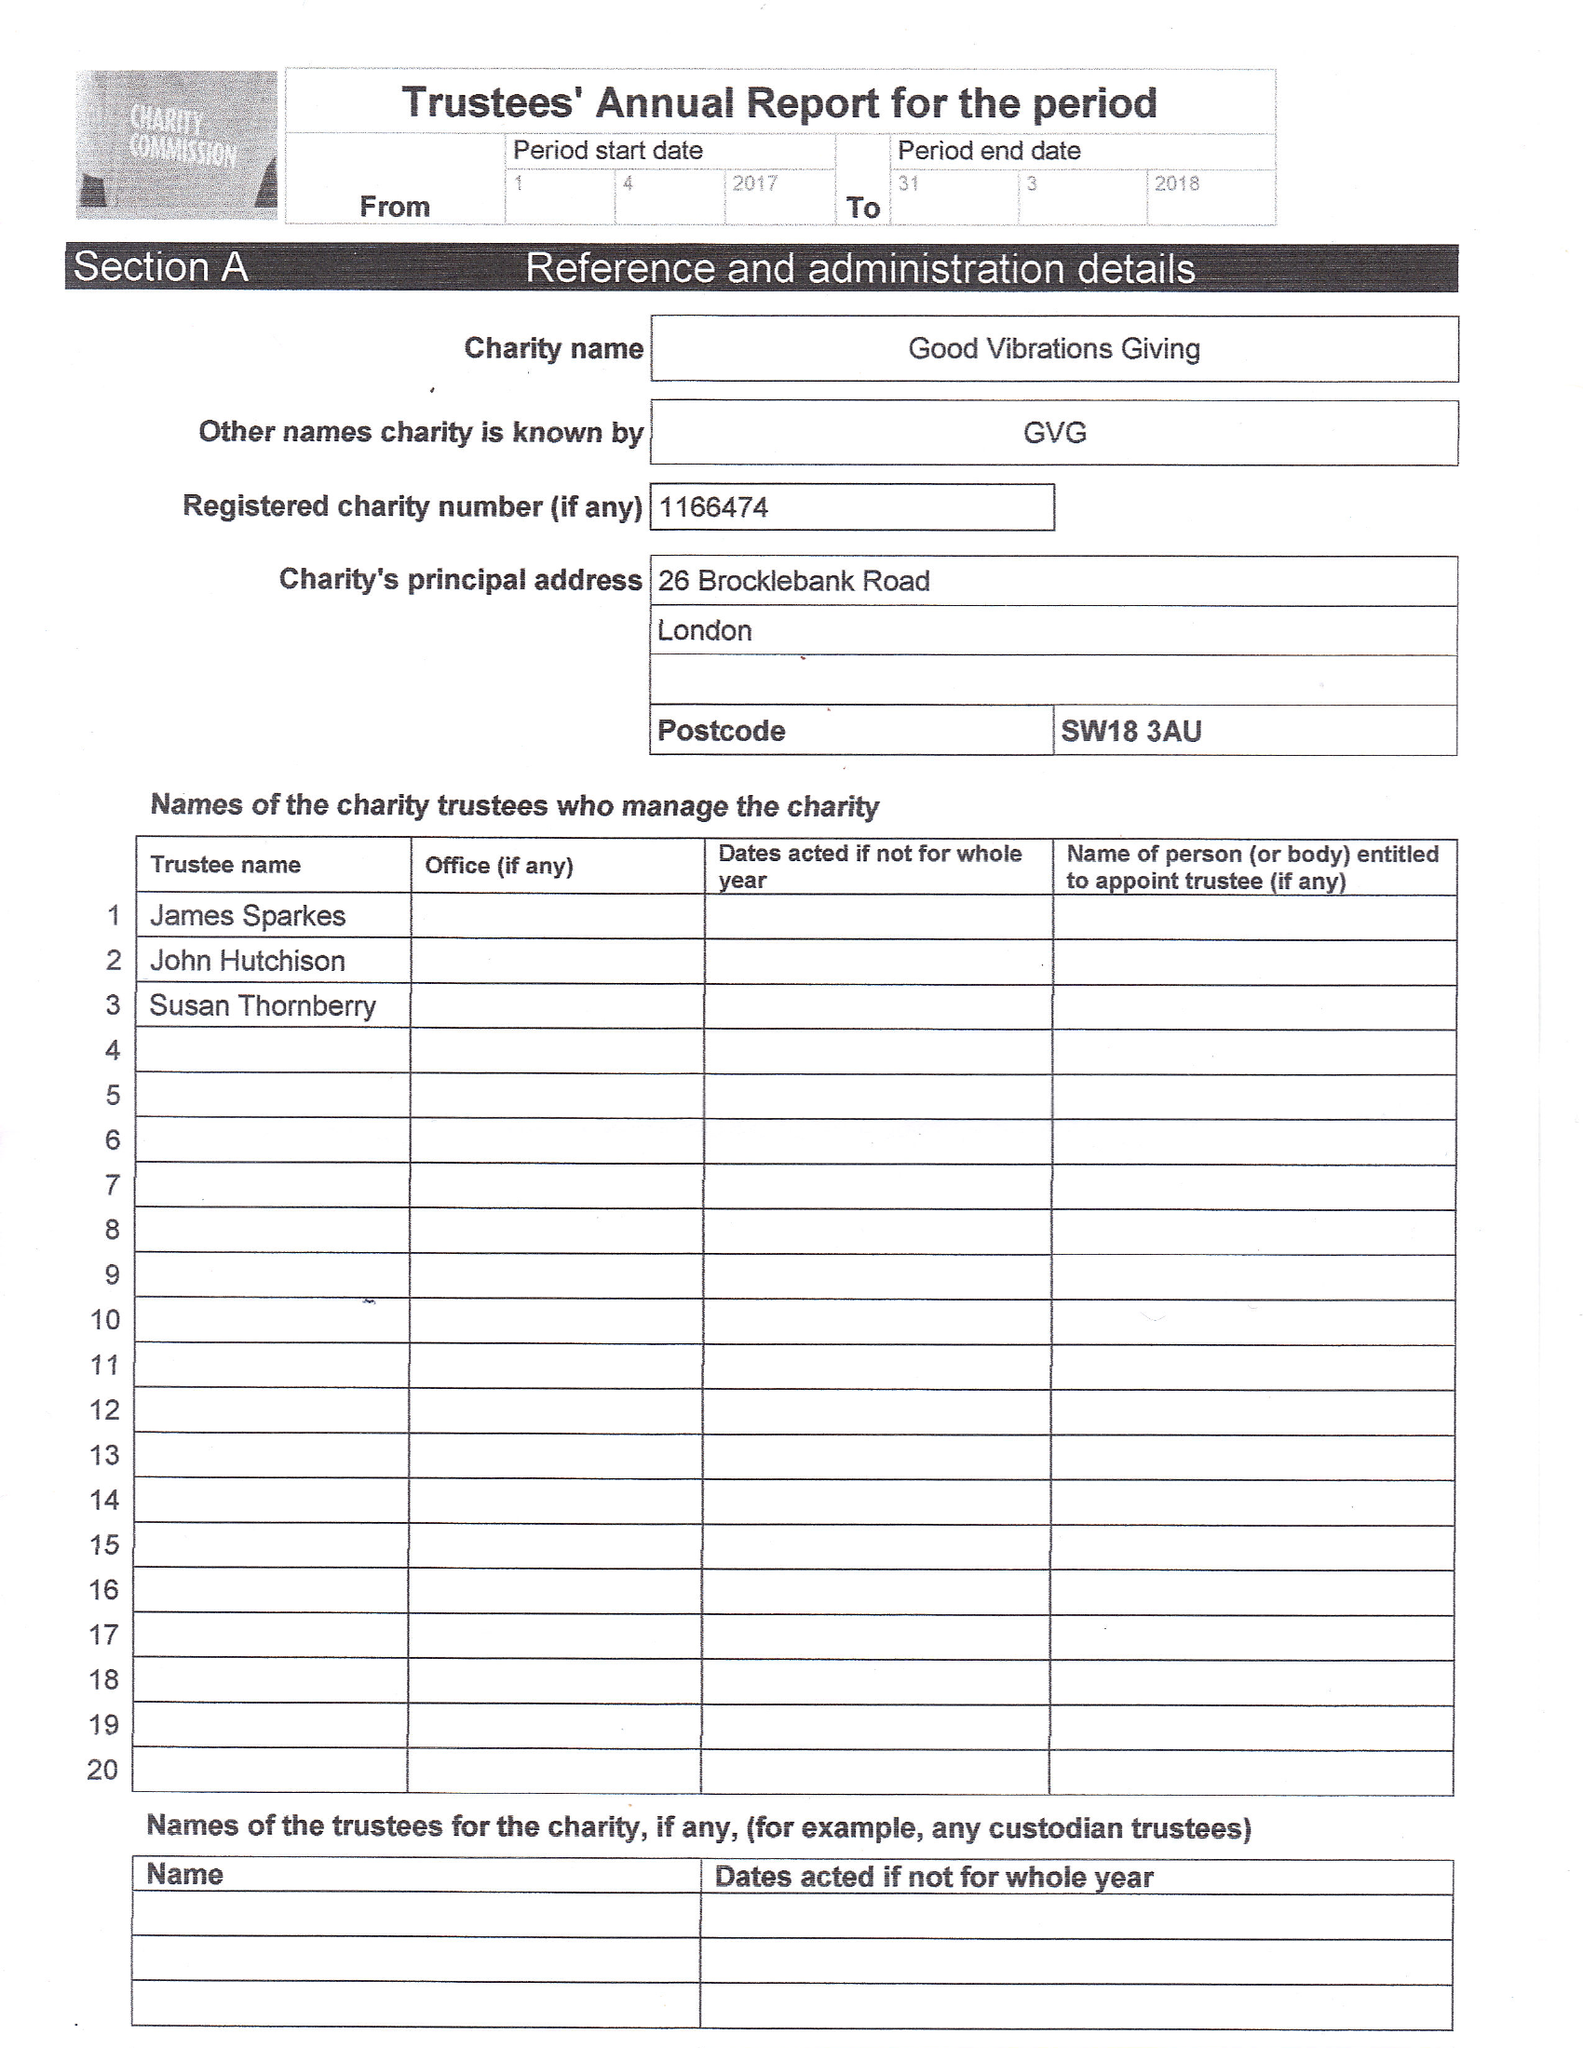What is the value for the address__street_line?
Answer the question using a single word or phrase. 26 BROCKLEBANK ROAD 